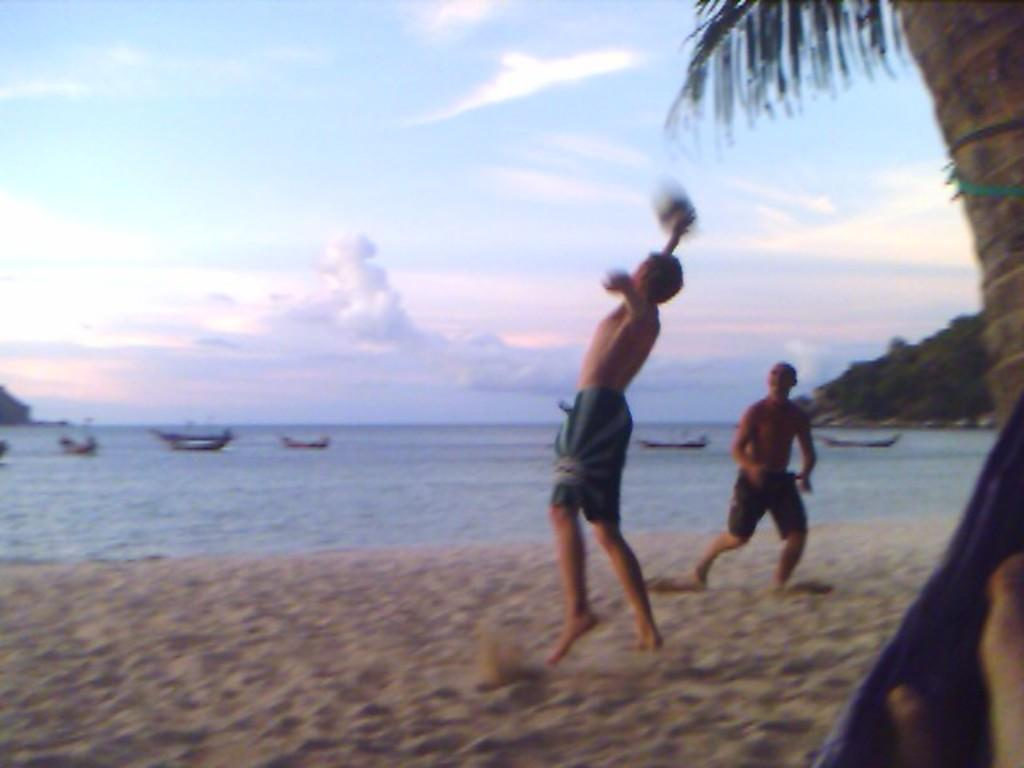Who or what can be seen in the image? There are people in the image. What is located beside the people? There is a tree beside the people. What can be seen in the distance in the image? Boats are visible in the background of the image. What is visible in the sky in the image? Clouds are present in the background of the image. What else can be seen in the background of the image? Trees are visible in the background of the image. What type of kite is being flown by the people in the image? There is no kite present in the image; it only features people, a tree, boats, clouds, and trees in the background. 